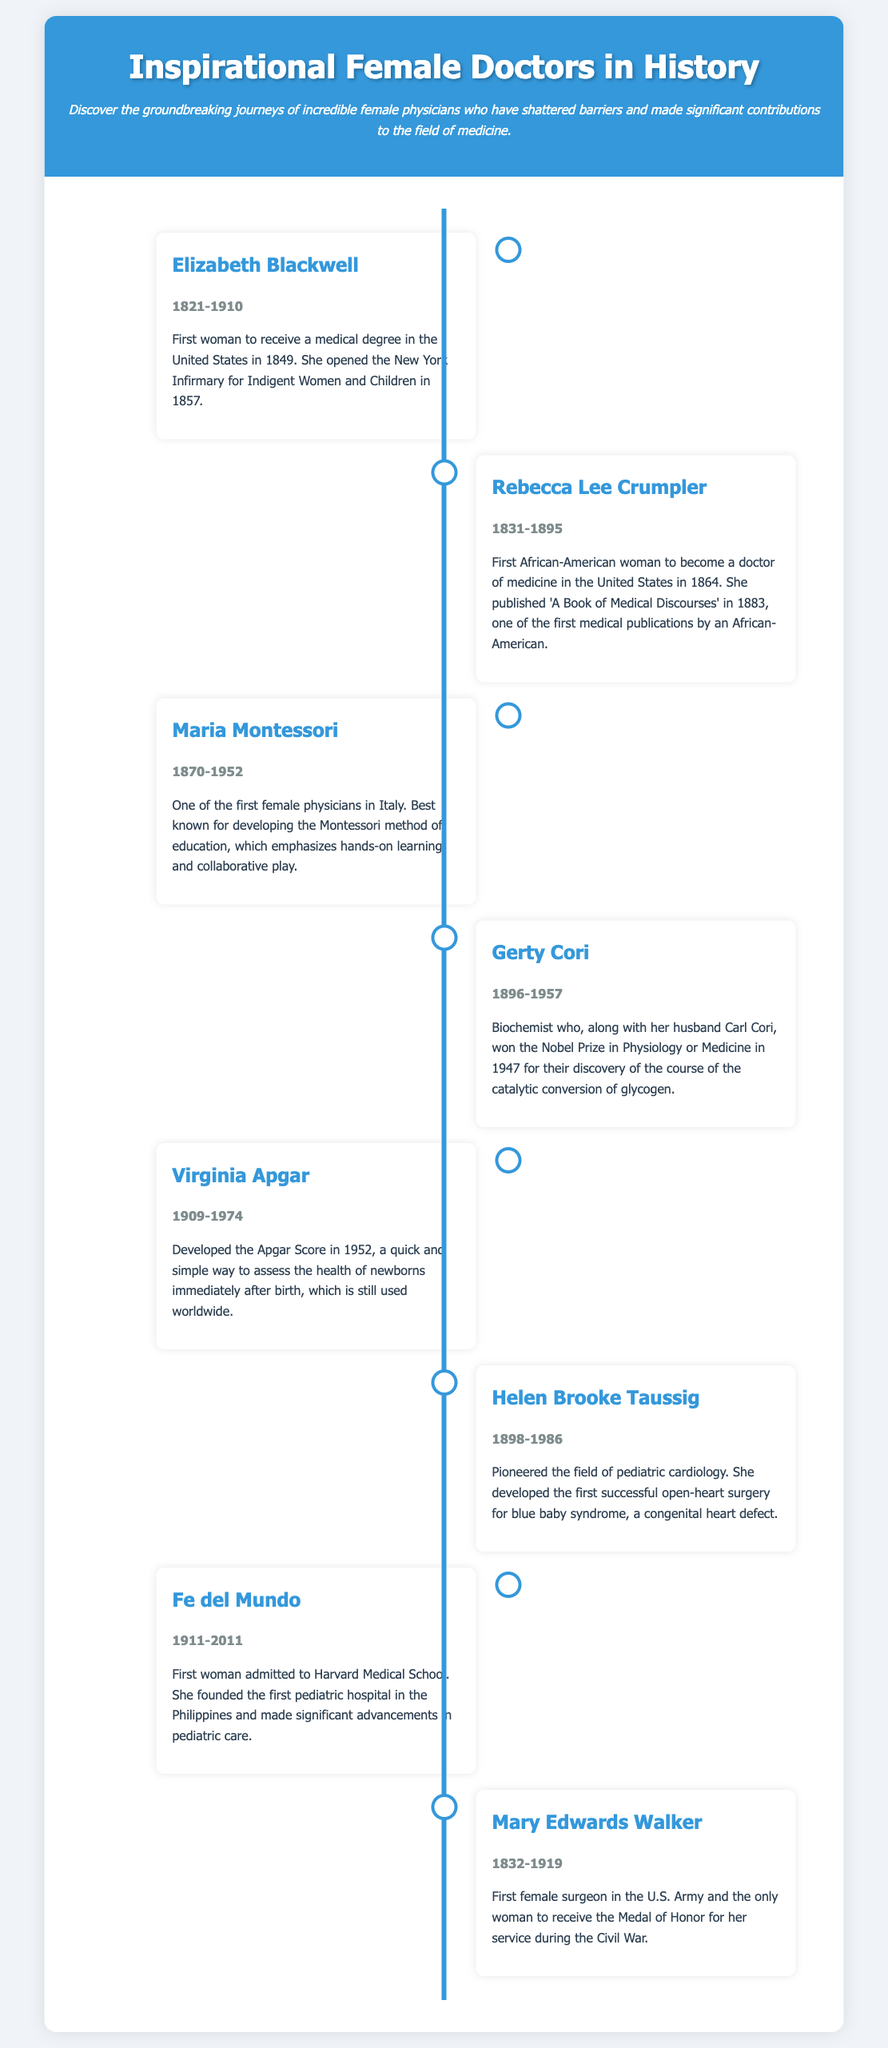What year did Elizabeth Blackwell receive her medical degree? Elizabeth Blackwell received her medical degree in 1849, as stated in her entry.
Answer: 1849 Who was the first African-American woman to become a doctor of medicine? The document identifies Rebecca Lee Crumpler as the first African-American woman to become a doctor of medicine.
Answer: Rebecca Lee Crumpler What was Maria Montessori known for? According to the document, Maria Montessori is best known for developing the Montessori method of education.
Answer: Montessori method In what year did Virginia Apgar develop the Apgar Score? The Apgar Score was developed by Virginia Apgar in 1952, according to her entry in the timeline.
Answer: 1952 How many female doctors are featured in this infographic? The document lists eight inspirational female doctors, as shown in the timeline.
Answer: Eight What is the unique achievement of Mary Edwards Walker? Mary Edwards Walker is noted as the first female surgeon in the U.S. Army and for receiving the Medal of Honor.
Answer: First female surgeon Which doctor founded the first pediatric hospital in the Philippines? The document mentions that Fe del Mundo founded the first pediatric hospital in the Philippines.
Answer: Fe del Mundo What significant contribution did Gerty Cori make in 1947? Gerty Cori, along with her husband, won the Nobel Prize in Physiology or Medicine in 1947.
Answer: Nobel Prize What is a distinctive feature of the document's layout? The document uses a timeline format to present the information about influential female doctors.
Answer: Timeline format 